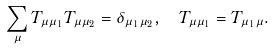Convert formula to latex. <formula><loc_0><loc_0><loc_500><loc_500>\sum _ { \mu } T _ { \mu \mu _ { 1 } } T _ { \mu \mu _ { 2 } } = \delta _ { \mu _ { 1 } \mu _ { 2 } } , \ \ T _ { \mu \mu _ { 1 } } = T _ { \mu _ { 1 } \mu } .</formula> 